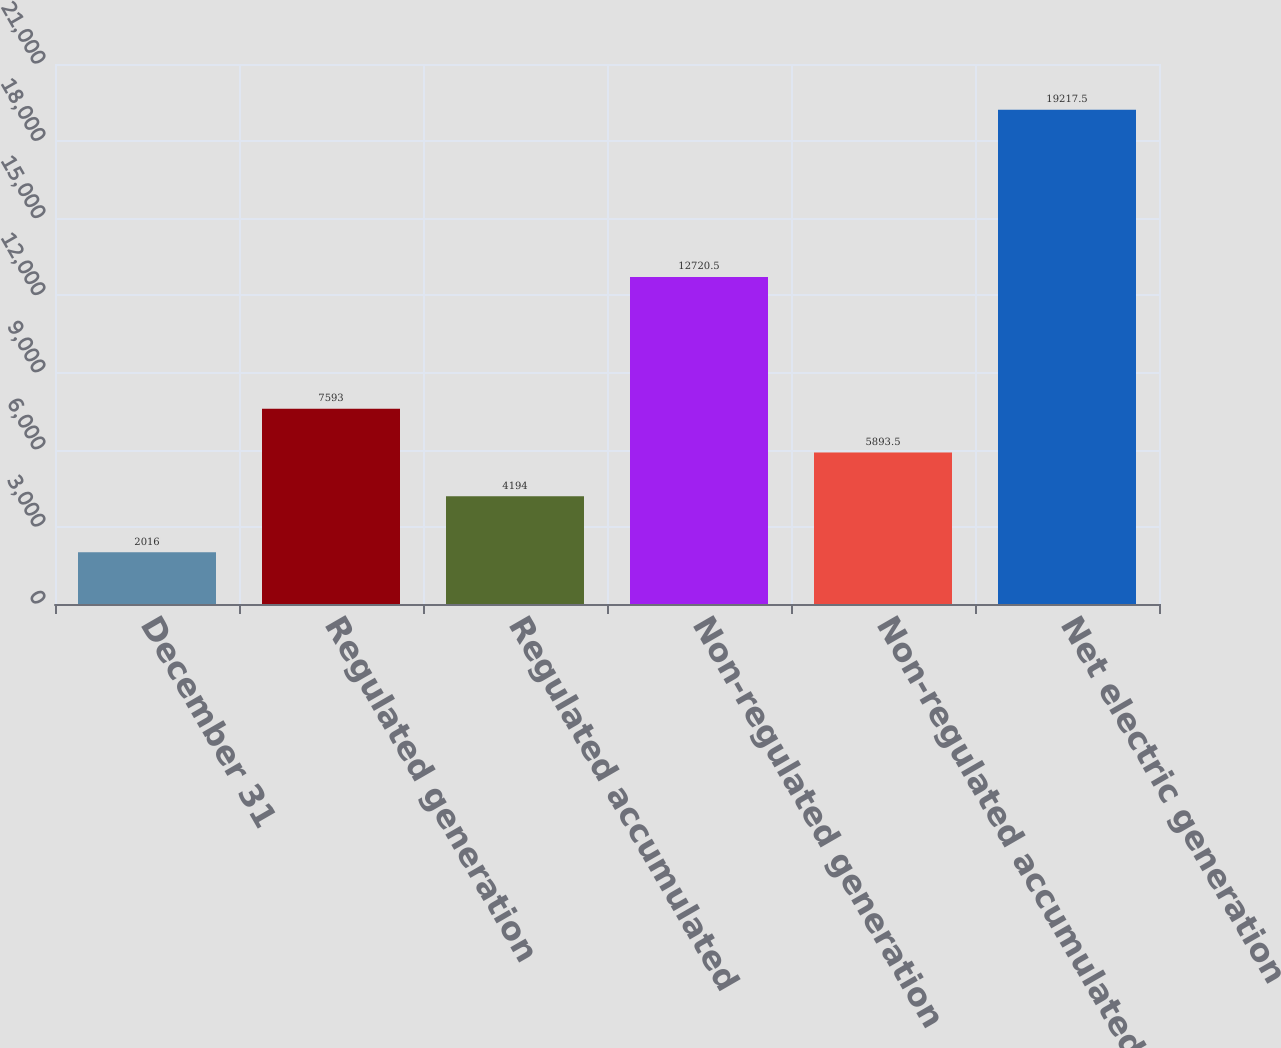Convert chart to OTSL. <chart><loc_0><loc_0><loc_500><loc_500><bar_chart><fcel>December 31<fcel>Regulated generation<fcel>Regulated accumulated<fcel>Non-regulated generation<fcel>Non-regulated accumulated<fcel>Net electric generation<nl><fcel>2016<fcel>7593<fcel>4194<fcel>12720.5<fcel>5893.5<fcel>19217.5<nl></chart> 